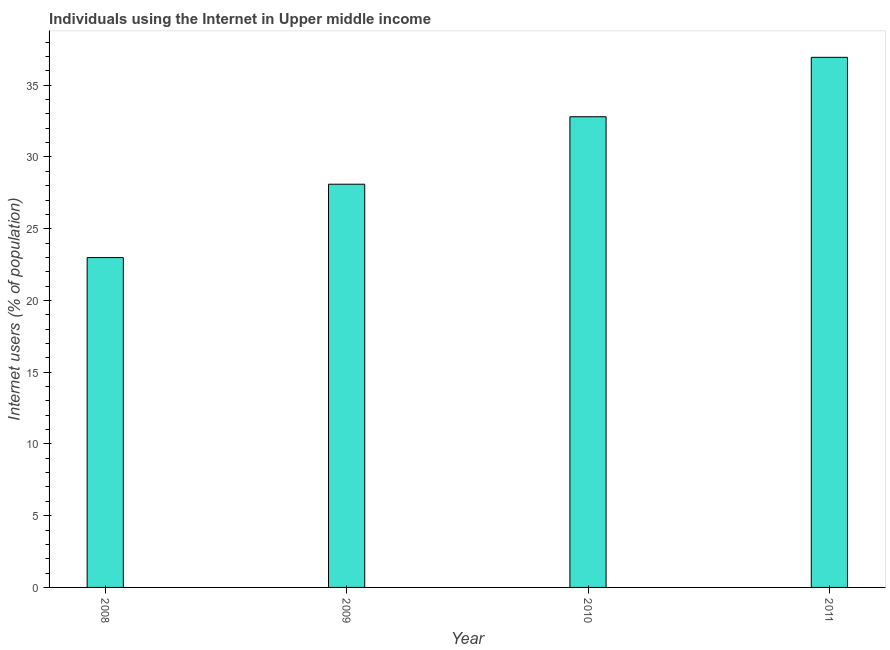Does the graph contain grids?
Offer a very short reply. No. What is the title of the graph?
Offer a very short reply. Individuals using the Internet in Upper middle income. What is the label or title of the Y-axis?
Keep it short and to the point. Internet users (% of population). What is the number of internet users in 2011?
Your response must be concise. 36.95. Across all years, what is the maximum number of internet users?
Offer a very short reply. 36.95. Across all years, what is the minimum number of internet users?
Provide a succinct answer. 22.99. In which year was the number of internet users maximum?
Ensure brevity in your answer.  2011. What is the sum of the number of internet users?
Your answer should be very brief. 120.84. What is the difference between the number of internet users in 2008 and 2010?
Give a very brief answer. -9.81. What is the average number of internet users per year?
Provide a succinct answer. 30.21. What is the median number of internet users?
Make the answer very short. 30.45. Do a majority of the years between 2008 and 2011 (inclusive) have number of internet users greater than 11 %?
Your response must be concise. Yes. What is the ratio of the number of internet users in 2009 to that in 2011?
Provide a succinct answer. 0.76. Is the number of internet users in 2009 less than that in 2010?
Provide a short and direct response. Yes. Is the difference between the number of internet users in 2008 and 2011 greater than the difference between any two years?
Provide a succinct answer. Yes. What is the difference between the highest and the second highest number of internet users?
Ensure brevity in your answer.  4.14. Is the sum of the number of internet users in 2008 and 2009 greater than the maximum number of internet users across all years?
Ensure brevity in your answer.  Yes. What is the difference between the highest and the lowest number of internet users?
Your answer should be very brief. 13.96. How many years are there in the graph?
Provide a short and direct response. 4. What is the difference between two consecutive major ticks on the Y-axis?
Keep it short and to the point. 5. What is the Internet users (% of population) of 2008?
Offer a terse response. 22.99. What is the Internet users (% of population) in 2009?
Make the answer very short. 28.1. What is the Internet users (% of population) of 2010?
Make the answer very short. 32.81. What is the Internet users (% of population) of 2011?
Offer a very short reply. 36.95. What is the difference between the Internet users (% of population) in 2008 and 2009?
Give a very brief answer. -5.11. What is the difference between the Internet users (% of population) in 2008 and 2010?
Ensure brevity in your answer.  -9.82. What is the difference between the Internet users (% of population) in 2008 and 2011?
Provide a succinct answer. -13.96. What is the difference between the Internet users (% of population) in 2009 and 2010?
Offer a terse response. -4.7. What is the difference between the Internet users (% of population) in 2009 and 2011?
Keep it short and to the point. -8.84. What is the difference between the Internet users (% of population) in 2010 and 2011?
Give a very brief answer. -4.14. What is the ratio of the Internet users (% of population) in 2008 to that in 2009?
Your answer should be very brief. 0.82. What is the ratio of the Internet users (% of population) in 2008 to that in 2010?
Provide a succinct answer. 0.7. What is the ratio of the Internet users (% of population) in 2008 to that in 2011?
Your answer should be compact. 0.62. What is the ratio of the Internet users (% of population) in 2009 to that in 2010?
Ensure brevity in your answer.  0.86. What is the ratio of the Internet users (% of population) in 2009 to that in 2011?
Provide a succinct answer. 0.76. What is the ratio of the Internet users (% of population) in 2010 to that in 2011?
Your response must be concise. 0.89. 